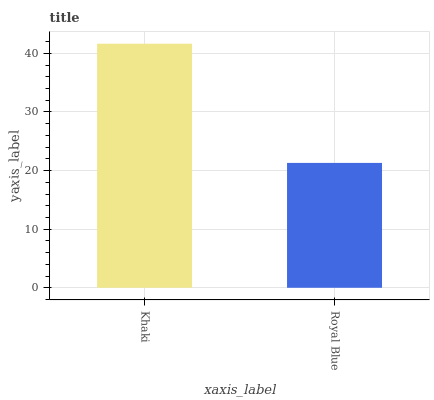Is Royal Blue the minimum?
Answer yes or no. Yes. Is Khaki the maximum?
Answer yes or no. Yes. Is Royal Blue the maximum?
Answer yes or no. No. Is Khaki greater than Royal Blue?
Answer yes or no. Yes. Is Royal Blue less than Khaki?
Answer yes or no. Yes. Is Royal Blue greater than Khaki?
Answer yes or no. No. Is Khaki less than Royal Blue?
Answer yes or no. No. Is Khaki the high median?
Answer yes or no. Yes. Is Royal Blue the low median?
Answer yes or no. Yes. Is Royal Blue the high median?
Answer yes or no. No. Is Khaki the low median?
Answer yes or no. No. 